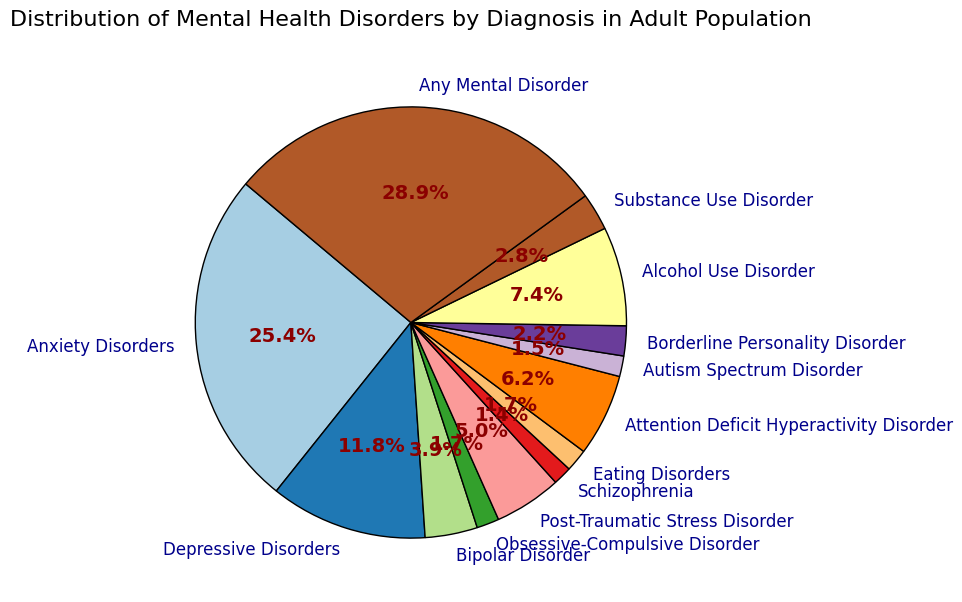What is the most common mental health disorder in the adult population? The largest section of the pie chart represents Anxiety Disorders. In the legend, Anxiety Disorders are labeled with the highest percentage at 18.1%.
Answer: Anxiety Disorders What is the combined percentage of Bipolar Disorder and Schizophrenia? To find the combined percentage, add the percentages of Bipolar Disorder and Schizophrenia: 2.8% + 1.0% = 3.8%.
Answer: 3.8% How does the percentage of Depressive Disorders compare with Attention Deficit Hyperactivity Disorder (ADHD)? Depressive Disorders have a percentage of 8.4%, while ADHD has a percentage of 4.4%. Depressive Disorders have a higher percentage than ADHD.
Answer: Depressive Disorders > ADHD Which disorder is represented by the smallest section of the pie chart? Schizophrenia is represented by the smallest section in the pie chart with a percentage of 1.0%.
Answer: Schizophrenia What is the difference in percentage between Alcohol Use Disorder and Substance Use Disorder? Subtract the percentage of Substance Use Disorder from that of Alcohol Use Disorder: 5.3% - 2.0% = 3.3%.
Answer: 3.3% What is the percentage of all disorders that have a percentage greater than 5%? The disorders with a percentage greater than 5% are Anxiety Disorders (18.1%), Depressive Disorders (8.4%), and Alcohol Use Disorder (5.3%). Summing these percentages: 18.1% + 8.4% + 5.3% = 31.8%.
Answer: 31.8% Compared to Autism Spectrum Disorder, how many times higher is the percentage of Any Mental Disorder? Any Mental Disorder is at 20.6%, whereas Autism Spectrum Disorder is at 1.1%. The ratio is 20.6 / 1.1 = 18.73, rounded to about 18.7 times higher.
Answer: 18.7 times If you combine the percentages of Post-Traumatic Stress Disorder and Obsessive-Compulsive Disorder, does it exceed the percentage of ADHD? The combined percentage of Post-Traumatic Stress Disorder (3.6%) and Obsessive-Compulsive Disorder (1.2%) is 3.6% + 1.2% = 4.8%, which is greater than the percentage of ADHD (4.4%).
Answer: Yes Which disorders have a percentage of 1.2%? Both Obsessive-Compulsive Disorder and Eating Disorders are shown with a percentage of 1.2% in the pie chart.
Answer: Obsessive-Compulsive Disorder, Eating Disorders 